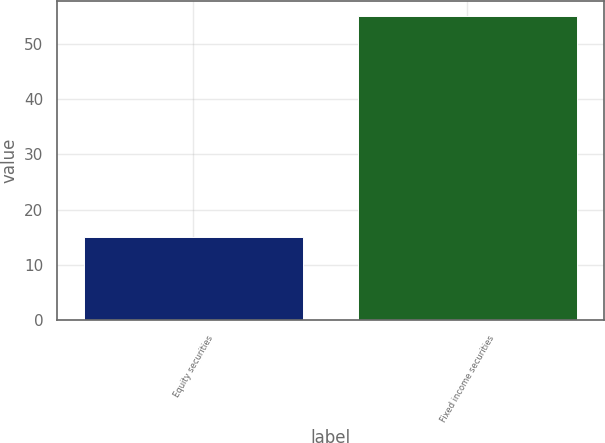<chart> <loc_0><loc_0><loc_500><loc_500><bar_chart><fcel>Equity securities<fcel>Fixed income securities<nl><fcel>15<fcel>55<nl></chart> 